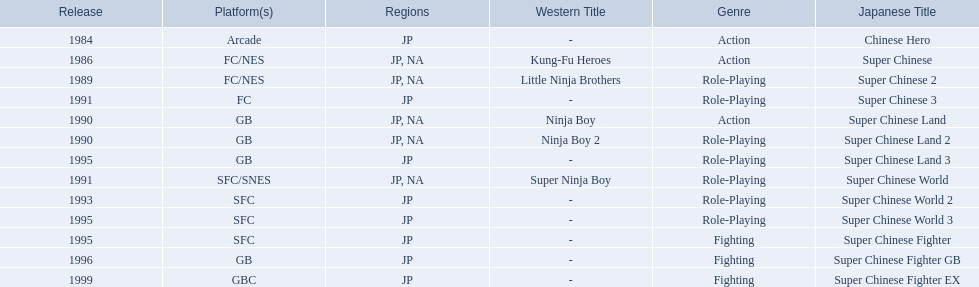Which titles were released in north america? Super Chinese, Super Chinese 2, Super Chinese Land, Super Chinese Land 2, Super Chinese World. Of those, which had the least releases? Super Chinese World. 